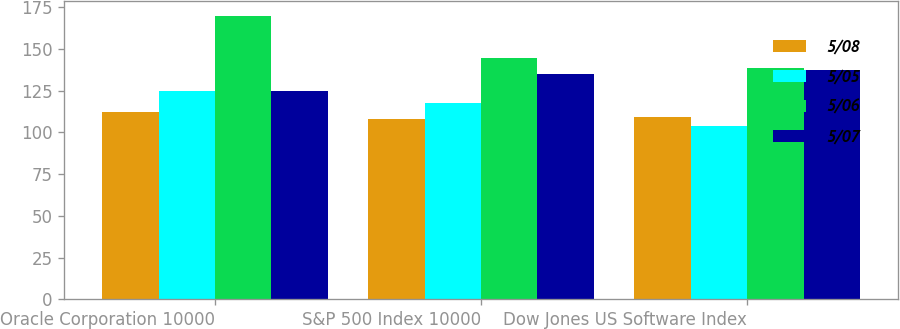<chart> <loc_0><loc_0><loc_500><loc_500><stacked_bar_chart><ecel><fcel>Oracle Corporation 10000<fcel>S&P 500 Index 10000<fcel>Dow Jones US Software Index<nl><fcel>5/08<fcel>112.28<fcel>108.24<fcel>109.39<nl><fcel>5/05<fcel>124.74<fcel>117.59<fcel>104.04<nl><fcel>5/06<fcel>170<fcel>144.39<fcel>138.31<nl><fcel>5/07<fcel>124.74<fcel>134.72<fcel>137.29<nl></chart> 